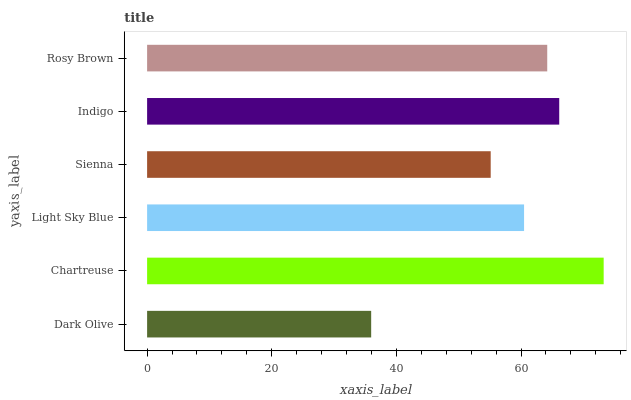Is Dark Olive the minimum?
Answer yes or no. Yes. Is Chartreuse the maximum?
Answer yes or no. Yes. Is Light Sky Blue the minimum?
Answer yes or no. No. Is Light Sky Blue the maximum?
Answer yes or no. No. Is Chartreuse greater than Light Sky Blue?
Answer yes or no. Yes. Is Light Sky Blue less than Chartreuse?
Answer yes or no. Yes. Is Light Sky Blue greater than Chartreuse?
Answer yes or no. No. Is Chartreuse less than Light Sky Blue?
Answer yes or no. No. Is Rosy Brown the high median?
Answer yes or no. Yes. Is Light Sky Blue the low median?
Answer yes or no. Yes. Is Chartreuse the high median?
Answer yes or no. No. Is Indigo the low median?
Answer yes or no. No. 